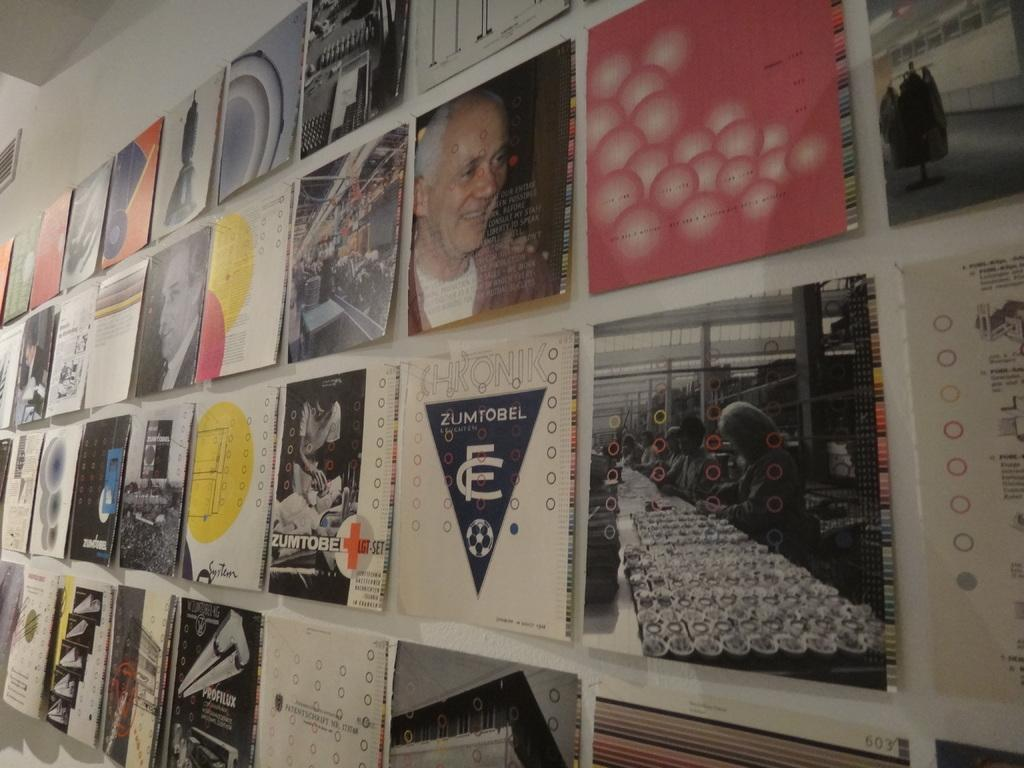<image>
Give a short and clear explanation of the subsequent image. A wall containing images and signs including signs for Zumtobel and Profilux. 